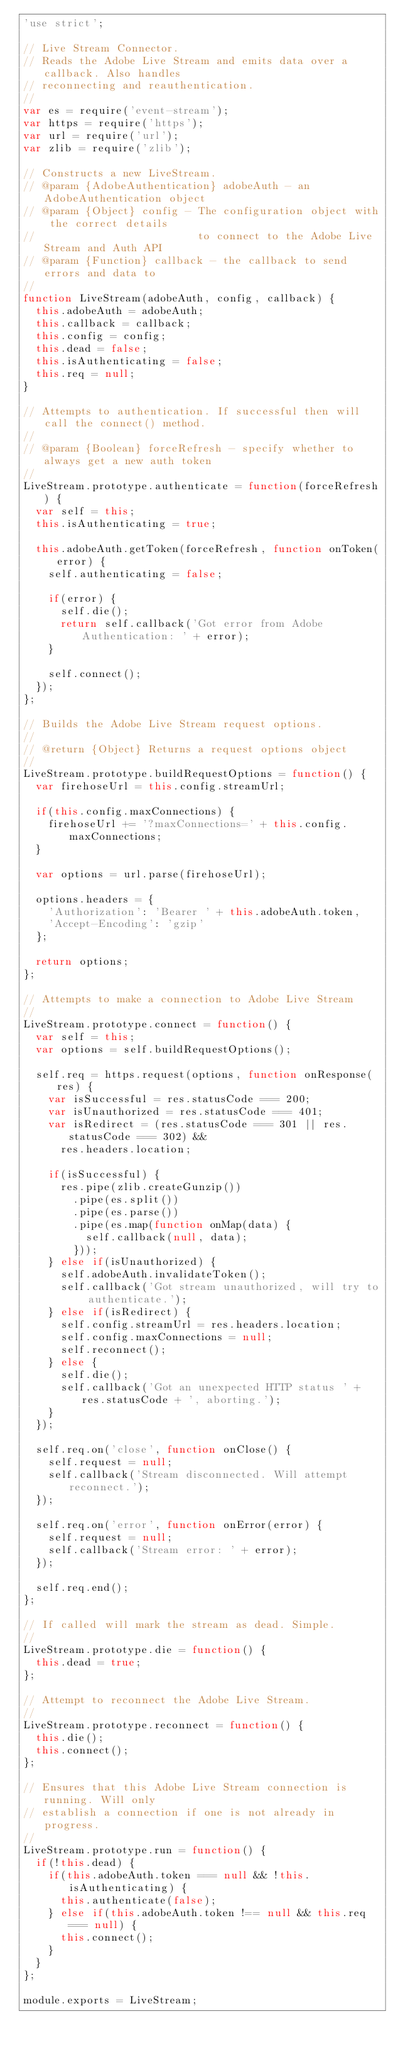<code> <loc_0><loc_0><loc_500><loc_500><_JavaScript_>'use strict';

// Live Stream Connector.
// Reads the Adobe Live Stream and emits data over a callback. Also handles
// reconnecting and reauthentication.
//
var es = require('event-stream');
var https = require('https');
var url = require('url');
var zlib = require('zlib');

// Constructs a new LiveStream.
// @param {AdobeAuthentication} adobeAuth - an AdobeAuthentication object
// @param {Object} config - The configuration object with the correct details
//                          to connect to the Adobe Live Stream and Auth API
// @param {Function} callback - the callback to send errors and data to
//
function LiveStream(adobeAuth, config, callback) {
  this.adobeAuth = adobeAuth;
  this.callback = callback;
  this.config = config;
  this.dead = false;
  this.isAuthenticating = false;
  this.req = null;
}

// Attempts to authentication. If successful then will call the connect() method.
//
// @param {Boolean} forceRefresh - specify whether to always get a new auth token
//
LiveStream.prototype.authenticate = function(forceRefresh) {
  var self = this;
  this.isAuthenticating = true;

  this.adobeAuth.getToken(forceRefresh, function onToken(error) {
    self.authenticating = false;

    if(error) {
      self.die();
      return self.callback('Got error from Adobe Authentication: ' + error);
    }

    self.connect();
  });
};

// Builds the Adobe Live Stream request options.
//
// @return {Object} Returns a request options object
//
LiveStream.prototype.buildRequestOptions = function() {
  var firehoseUrl = this.config.streamUrl;

  if(this.config.maxConnections) {
    firehoseUrl += '?maxConnections=' + this.config.maxConnections;
  }

  var options = url.parse(firehoseUrl);

  options.headers = {
    'Authorization': 'Bearer ' + this.adobeAuth.token,
    'Accept-Encoding': 'gzip'
  };

  return options;
};

// Attempts to make a connection to Adobe Live Stream
//
LiveStream.prototype.connect = function() {
  var self = this;
  var options = self.buildRequestOptions();

  self.req = https.request(options, function onResponse(res) {
    var isSuccessful = res.statusCode === 200;
    var isUnauthorized = res.statusCode === 401;
    var isRedirect = (res.statusCode === 301 || res.statusCode === 302) &&
      res.headers.location;

    if(isSuccessful) {
      res.pipe(zlib.createGunzip())
        .pipe(es.split())
        .pipe(es.parse())
        .pipe(es.map(function onMap(data) {
          self.callback(null, data);
        }));
    } else if(isUnauthorized) {
      self.adobeAuth.invalidateToken();
      self.callback('Got stream unauthorized, will try to authenticate.');
    } else if(isRedirect) {
      self.config.streamUrl = res.headers.location;
      self.config.maxConnections = null;
      self.reconnect();
    } else {
      self.die();
      self.callback('Got an unexpected HTTP status ' + res.statusCode + ', aborting.');
    }
  });

  self.req.on('close', function onClose() {
    self.request = null;
    self.callback('Stream disconnected. Will attempt reconnect.');
  });

  self.req.on('error', function onError(error) {
    self.request = null;
    self.callback('Stream error: ' + error);
  });

  self.req.end();
};

// If called will mark the stream as dead. Simple.
//
LiveStream.prototype.die = function() {
  this.dead = true;
};

// Attempt to reconnect the Adobe Live Stream.
//
LiveStream.prototype.reconnect = function() {
  this.die();
  this.connect();
};

// Ensures that this Adobe Live Stream connection is running. Will only
// establish a connection if one is not already in progress.
//
LiveStream.prototype.run = function() {
  if(!this.dead) {
    if(this.adobeAuth.token === null && !this.isAuthenticating) {
      this.authenticate(false);
    } else if(this.adobeAuth.token !== null && this.req === null) {
      this.connect();
    }
  }
};

module.exports = LiveStream;</code> 